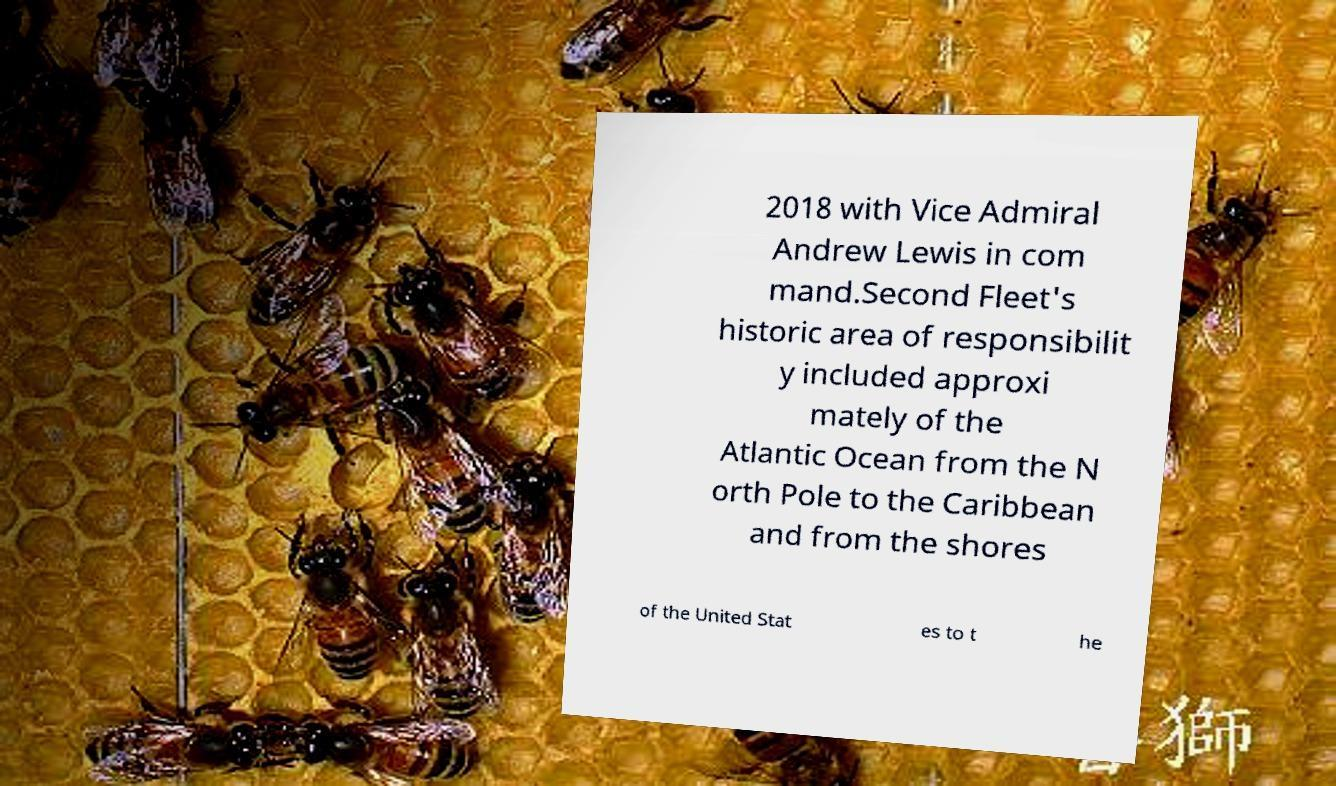There's text embedded in this image that I need extracted. Can you transcribe it verbatim? 2018 with Vice Admiral Andrew Lewis in com mand.Second Fleet's historic area of responsibilit y included approxi mately of the Atlantic Ocean from the N orth Pole to the Caribbean and from the shores of the United Stat es to t he 